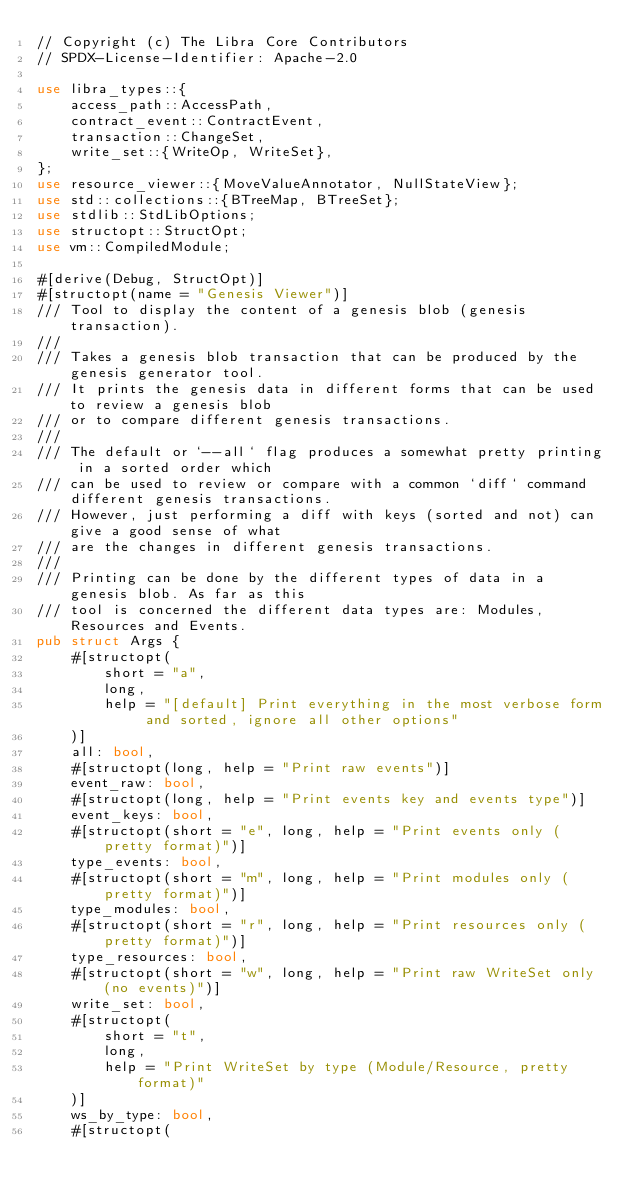<code> <loc_0><loc_0><loc_500><loc_500><_Rust_>// Copyright (c) The Libra Core Contributors
// SPDX-License-Identifier: Apache-2.0

use libra_types::{
    access_path::AccessPath,
    contract_event::ContractEvent,
    transaction::ChangeSet,
    write_set::{WriteOp, WriteSet},
};
use resource_viewer::{MoveValueAnnotator, NullStateView};
use std::collections::{BTreeMap, BTreeSet};
use stdlib::StdLibOptions;
use structopt::StructOpt;
use vm::CompiledModule;

#[derive(Debug, StructOpt)]
#[structopt(name = "Genesis Viewer")]
/// Tool to display the content of a genesis blob (genesis transaction).
///
/// Takes a genesis blob transaction that can be produced by the genesis generator tool.
/// It prints the genesis data in different forms that can be used to review a genesis blob
/// or to compare different genesis transactions.
///
/// The default or `--all` flag produces a somewhat pretty printing in a sorted order which
/// can be used to review or compare with a common `diff` command different genesis transactions.
/// However, just performing a diff with keys (sorted and not) can give a good sense of what
/// are the changes in different genesis transactions.
///
/// Printing can be done by the different types of data in a genesis blob. As far as this
/// tool is concerned the different data types are: Modules, Resources and Events.
pub struct Args {
    #[structopt(
        short = "a",
        long,
        help = "[default] Print everything in the most verbose form and sorted, ignore all other options"
    )]
    all: bool,
    #[structopt(long, help = "Print raw events")]
    event_raw: bool,
    #[structopt(long, help = "Print events key and events type")]
    event_keys: bool,
    #[structopt(short = "e", long, help = "Print events only (pretty format)")]
    type_events: bool,
    #[structopt(short = "m", long, help = "Print modules only (pretty format)")]
    type_modules: bool,
    #[structopt(short = "r", long, help = "Print resources only (pretty format)")]
    type_resources: bool,
    #[structopt(short = "w", long, help = "Print raw WriteSet only (no events)")]
    write_set: bool,
    #[structopt(
        short = "t",
        long,
        help = "Print WriteSet by type (Module/Resource, pretty format)"
    )]
    ws_by_type: bool,
    #[structopt(</code> 